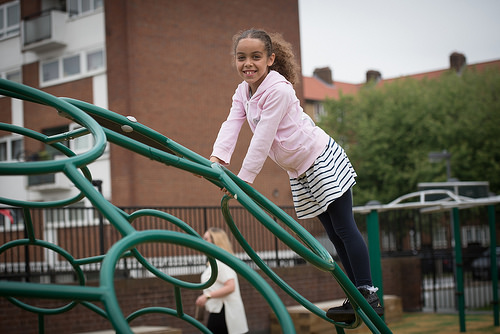<image>
Can you confirm if the girl is under the jungle gym? No. The girl is not positioned under the jungle gym. The vertical relationship between these objects is different. 